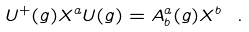Convert formula to latex. <formula><loc_0><loc_0><loc_500><loc_500>U ^ { + } ( g ) X ^ { a } U ( g ) = A _ { b } ^ { a } ( g ) X ^ { b } \ .</formula> 